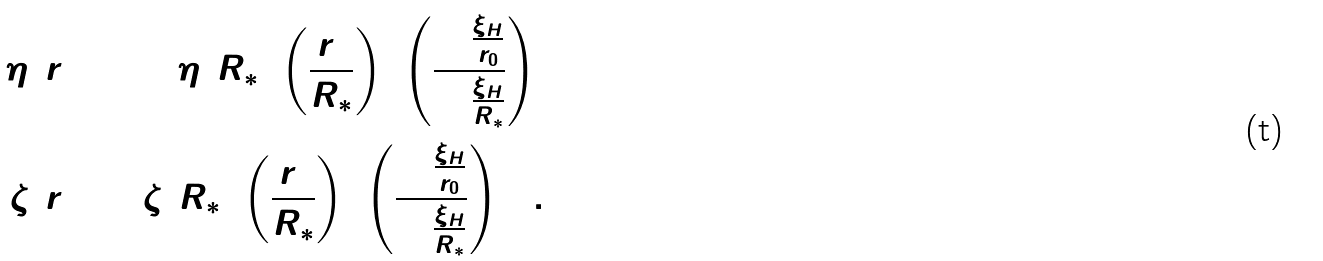<formula> <loc_0><loc_0><loc_500><loc_500>\Delta \eta ( r _ { 0 } ) & = \Delta \eta ( R _ { * } ) \left ( \frac { r _ { 0 } } { R _ { * } } \right ) ^ { 2 } \left ( \frac { \ln \frac { \xi _ { H } } { r _ { 0 } } } { \ln \frac { \xi _ { H } } { R _ { * } } } \right ) ^ { 3 } \\ \zeta ( r _ { 0 } ) & = \zeta ( R _ { * } ) \left ( \frac { r _ { 0 } } { R _ { * } } \right ) ^ { 2 } \left ( \frac { \ln \frac { \xi _ { H } } { r _ { 0 } } } { \ln \frac { \xi _ { H } } { R _ { * } } } \right ) ^ { 2 1 } .</formula> 